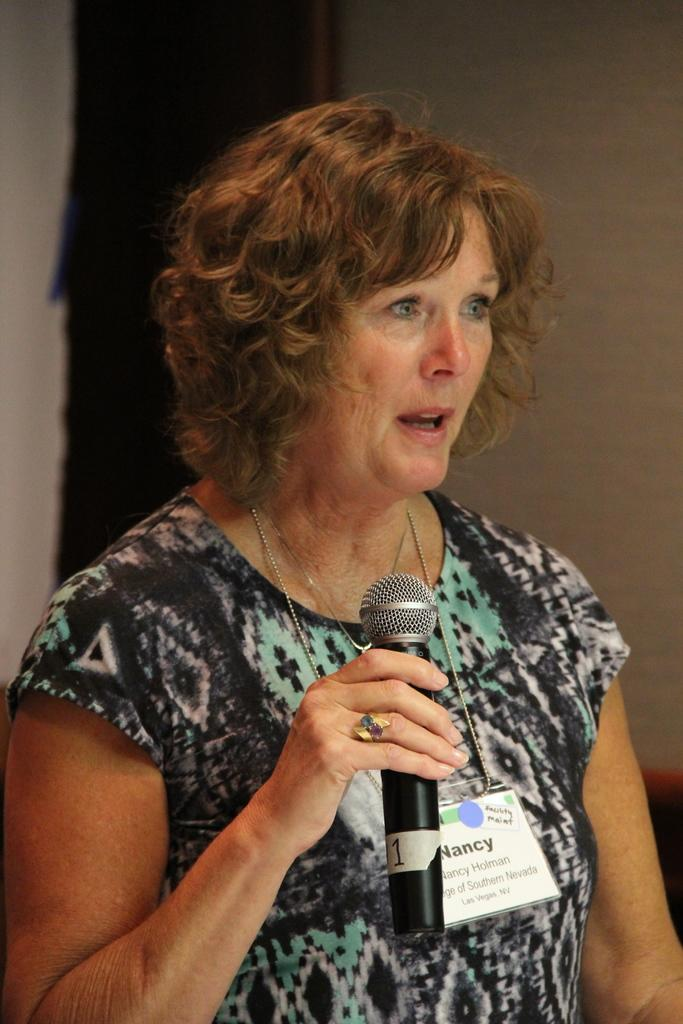Who is the main subject in the image? There is a lady in the image. What is the lady doing in the image? The lady is standing and holding a mic in her hand. What can be seen in the background of the image? There is a wall in the background of the image. What type of soup is the lady eating in the image? There is no soup present in the image; the lady is holding a mic. 